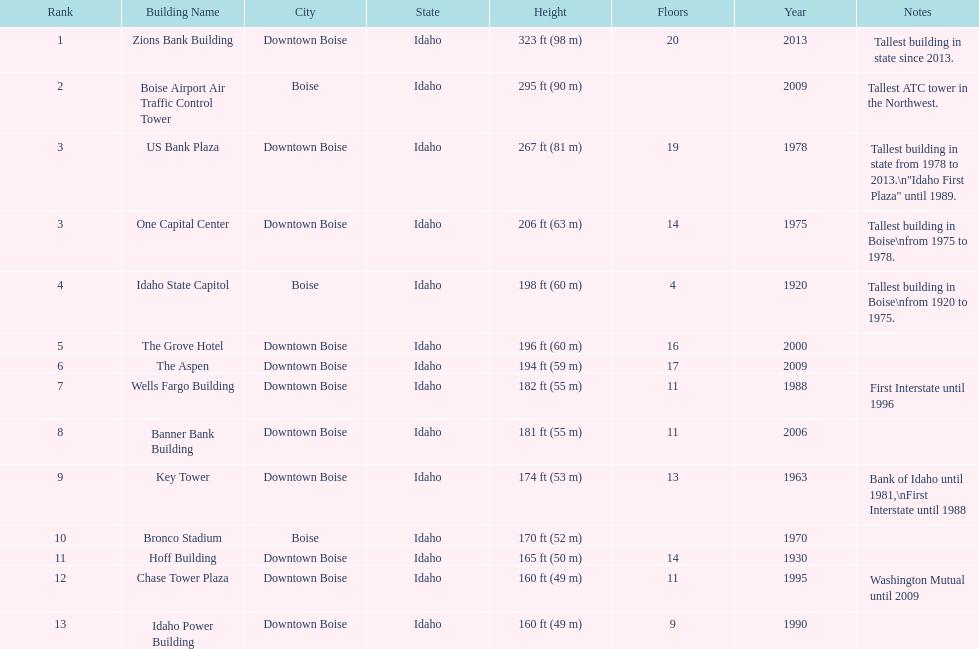What is the name of the building listed after idaho state capitol? The Grove Hotel. 